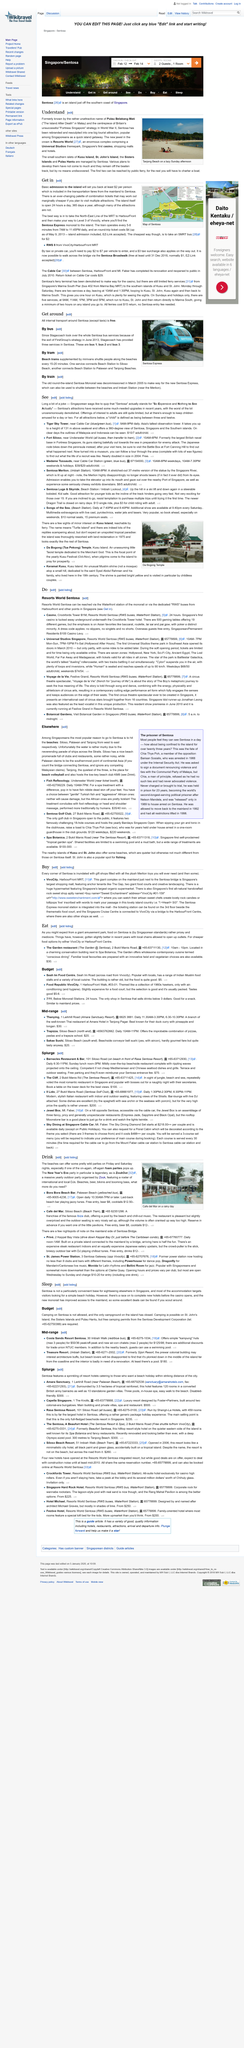Highlight a few significant elements in this photo. The Sentosa Express monorail operates a train to the island every 5-8 minutes from 7am to 11:45pm daily, offering a convenient transportation option for visitors to access the island. Chartering a boat is the primary method for accessing the Sisters Islands and Pulau Hantu. The cost of getting on the island is at least $2 per person. The island is open 24 hours a day, 365 days a year, with many of its attractions being available for visitors to enjoy at any time. Tanjong Beach is located in Singapore, a country known for its vibrant culture and modern cityscapes. 